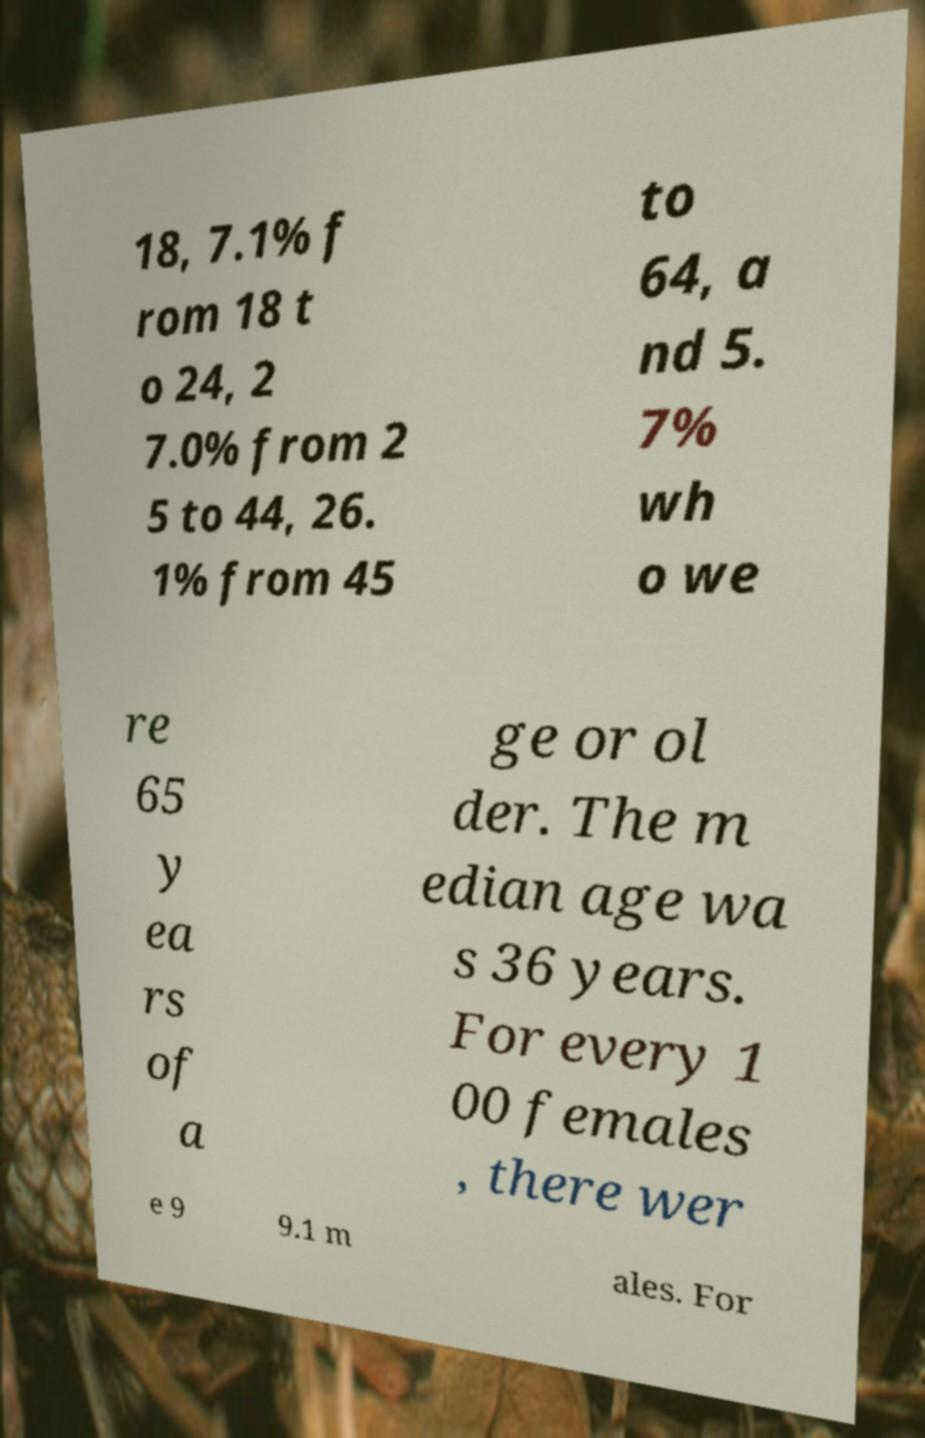There's text embedded in this image that I need extracted. Can you transcribe it verbatim? 18, 7.1% f rom 18 t o 24, 2 7.0% from 2 5 to 44, 26. 1% from 45 to 64, a nd 5. 7% wh o we re 65 y ea rs of a ge or ol der. The m edian age wa s 36 years. For every 1 00 females , there wer e 9 9.1 m ales. For 